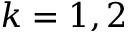Convert formula to latex. <formula><loc_0><loc_0><loc_500><loc_500>k = 1 , 2</formula> 